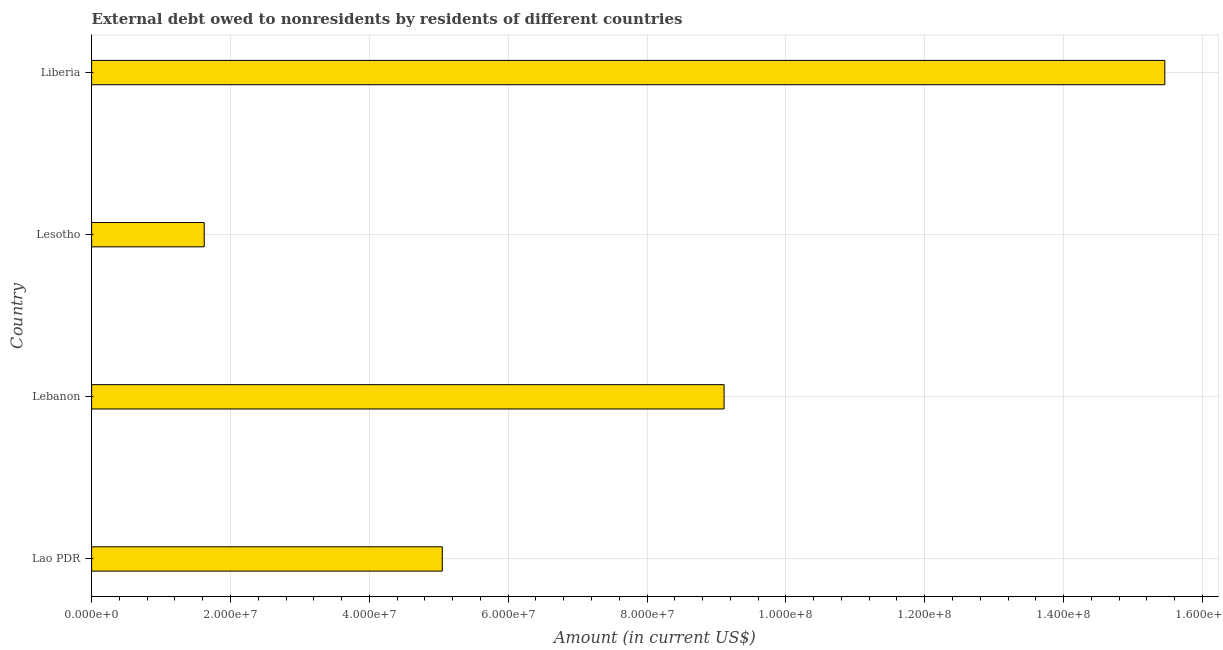What is the title of the graph?
Ensure brevity in your answer.  External debt owed to nonresidents by residents of different countries. What is the label or title of the X-axis?
Your response must be concise. Amount (in current US$). What is the label or title of the Y-axis?
Your answer should be compact. Country. What is the debt in Liberia?
Your response must be concise. 1.55e+08. Across all countries, what is the maximum debt?
Keep it short and to the point. 1.55e+08. Across all countries, what is the minimum debt?
Offer a very short reply. 1.62e+07. In which country was the debt maximum?
Make the answer very short. Liberia. In which country was the debt minimum?
Offer a very short reply. Lesotho. What is the sum of the debt?
Offer a very short reply. 3.12e+08. What is the difference between the debt in Lao PDR and Lebanon?
Your answer should be compact. -4.06e+07. What is the average debt per country?
Provide a short and direct response. 7.81e+07. What is the median debt?
Your response must be concise. 7.08e+07. What is the ratio of the debt in Lao PDR to that in Lesotho?
Ensure brevity in your answer.  3.11. Is the debt in Lebanon less than that in Liberia?
Your answer should be compact. Yes. What is the difference between the highest and the second highest debt?
Your response must be concise. 6.35e+07. Is the sum of the debt in Lao PDR and Lesotho greater than the maximum debt across all countries?
Make the answer very short. No. What is the difference between the highest and the lowest debt?
Your answer should be very brief. 1.38e+08. In how many countries, is the debt greater than the average debt taken over all countries?
Your response must be concise. 2. Are all the bars in the graph horizontal?
Offer a terse response. Yes. What is the Amount (in current US$) of Lao PDR?
Make the answer very short. 5.05e+07. What is the Amount (in current US$) in Lebanon?
Make the answer very short. 9.11e+07. What is the Amount (in current US$) in Lesotho?
Offer a terse response. 1.62e+07. What is the Amount (in current US$) in Liberia?
Offer a terse response. 1.55e+08. What is the difference between the Amount (in current US$) in Lao PDR and Lebanon?
Provide a short and direct response. -4.06e+07. What is the difference between the Amount (in current US$) in Lao PDR and Lesotho?
Provide a succinct answer. 3.43e+07. What is the difference between the Amount (in current US$) in Lao PDR and Liberia?
Keep it short and to the point. -1.04e+08. What is the difference between the Amount (in current US$) in Lebanon and Lesotho?
Ensure brevity in your answer.  7.49e+07. What is the difference between the Amount (in current US$) in Lebanon and Liberia?
Ensure brevity in your answer.  -6.35e+07. What is the difference between the Amount (in current US$) in Lesotho and Liberia?
Your response must be concise. -1.38e+08. What is the ratio of the Amount (in current US$) in Lao PDR to that in Lebanon?
Ensure brevity in your answer.  0.55. What is the ratio of the Amount (in current US$) in Lao PDR to that in Lesotho?
Provide a short and direct response. 3.11. What is the ratio of the Amount (in current US$) in Lao PDR to that in Liberia?
Your response must be concise. 0.33. What is the ratio of the Amount (in current US$) in Lebanon to that in Lesotho?
Make the answer very short. 5.62. What is the ratio of the Amount (in current US$) in Lebanon to that in Liberia?
Give a very brief answer. 0.59. What is the ratio of the Amount (in current US$) in Lesotho to that in Liberia?
Your answer should be compact. 0.1. 